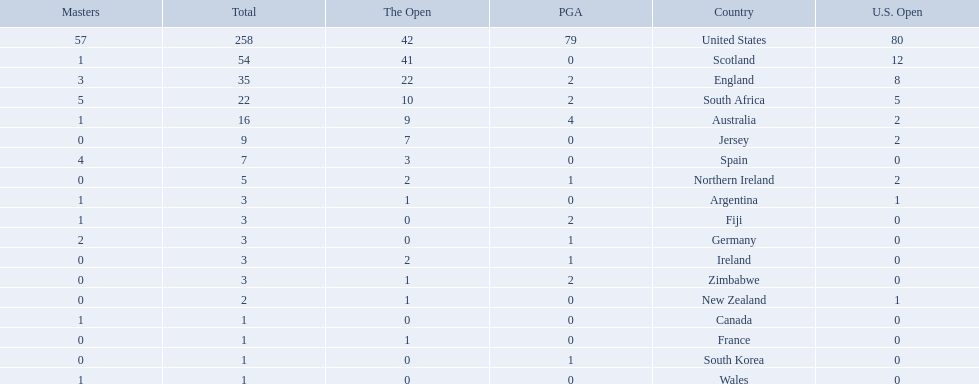What are all the countries? United States, Scotland, England, South Africa, Australia, Jersey, Spain, Northern Ireland, Argentina, Fiji, Germany, Ireland, Zimbabwe, New Zealand, Canada, France, South Korea, Wales. Which ones are located in africa? South Africa, Zimbabwe. Of those, which has the least champion golfers? Zimbabwe. Which of the countries listed are african? South Africa, Zimbabwe. Which of those has the least championship winning golfers? Zimbabwe. 